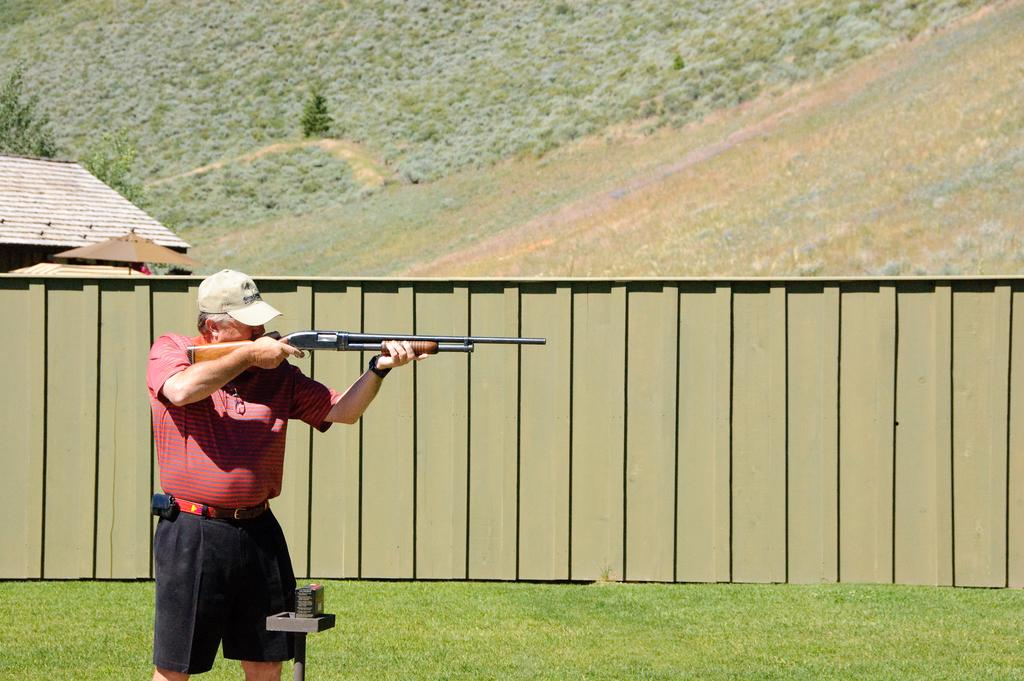What is the main subject of the image? There is a person standing in the image. Can you describe the person's attire? The person is wearing clothes and a cap. What is the person holding in the image? The person is holding a rifle in his hands. What type of vegetation can be seen in the image? There is grass and plants visible in the image. What is the background of the image? There is a wall in the image. What type of tongue can be seen sticking out of the person's mouth in the image? There is no tongue visible in the person's mouth in the image. 